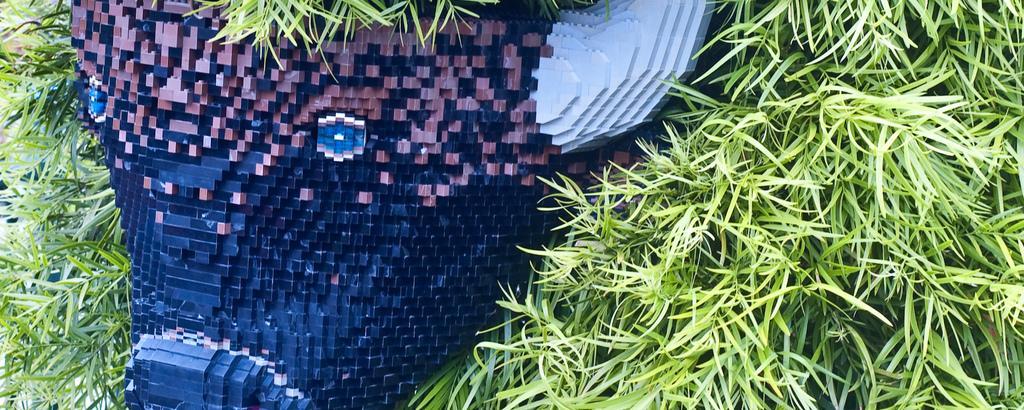In one or two sentences, can you explain what this image depicts? In this image in the front there is grass and there is an object which is blue and red in colour and gray in colour. 